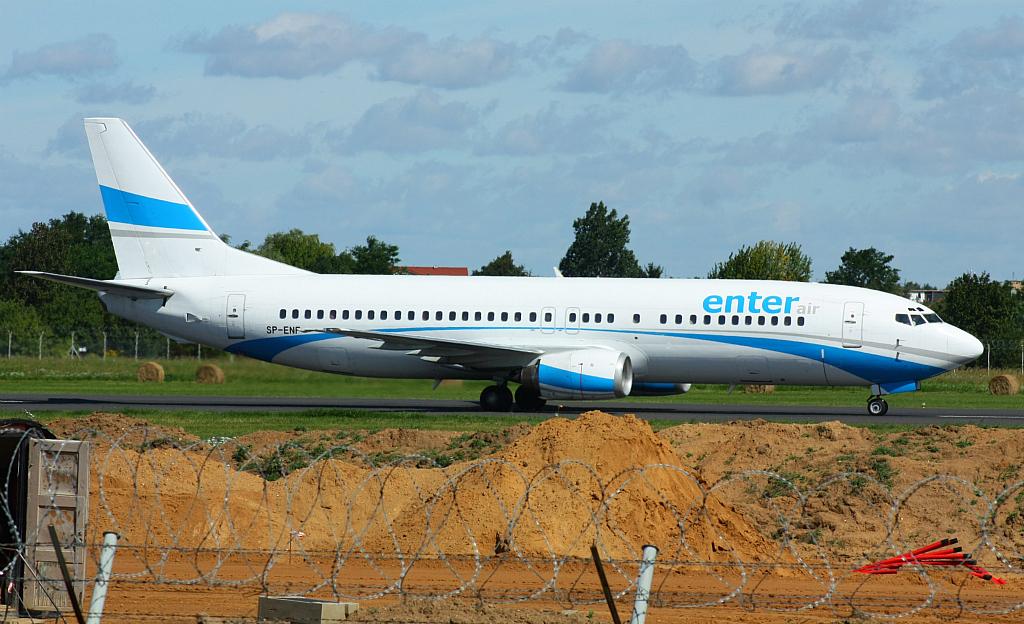What airline is this?
Ensure brevity in your answer.  Enter. What letters follow sp-?
Provide a short and direct response. Enf. 